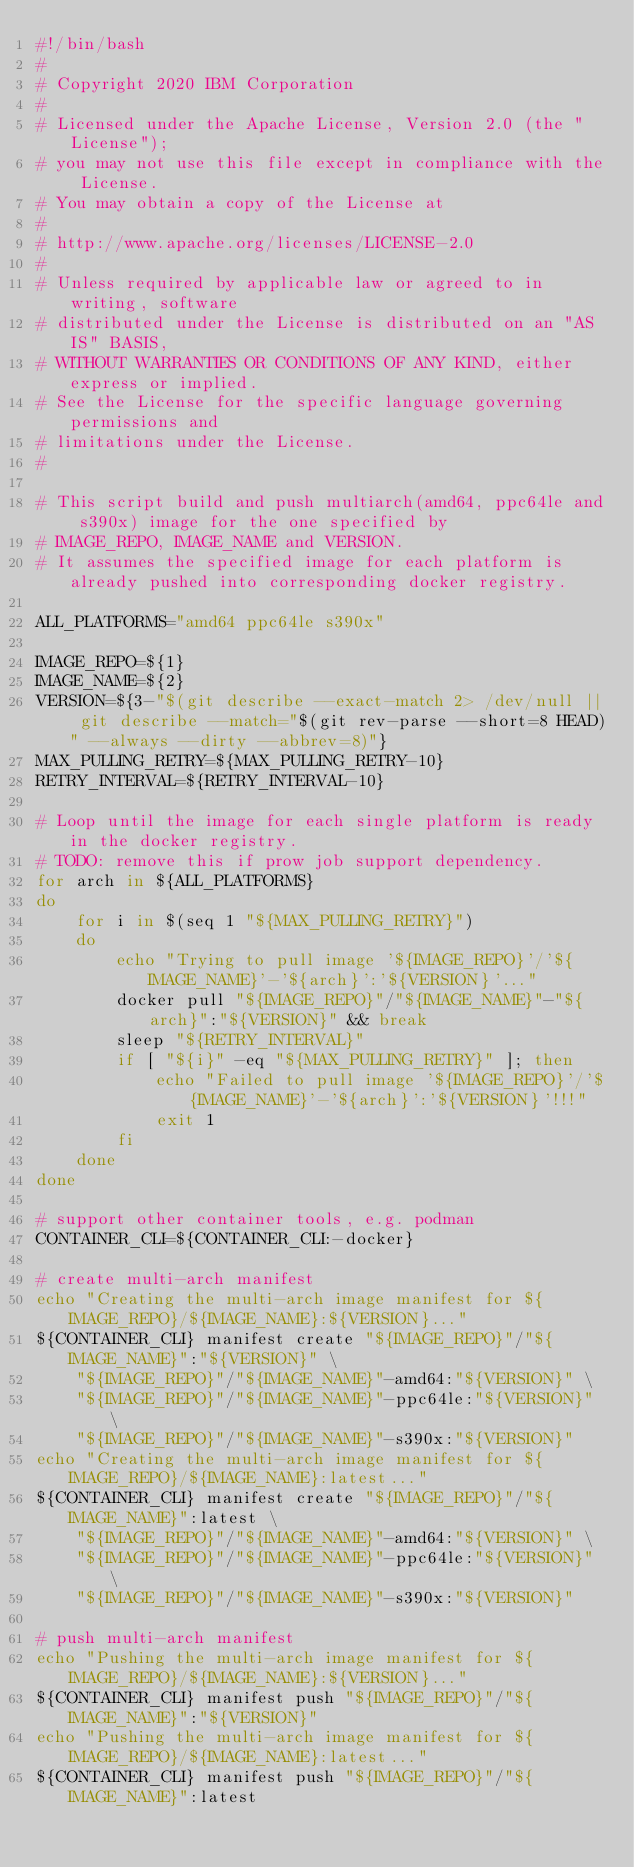Convert code to text. <code><loc_0><loc_0><loc_500><loc_500><_Bash_>#!/bin/bash
#
# Copyright 2020 IBM Corporation
#
# Licensed under the Apache License, Version 2.0 (the "License");
# you may not use this file except in compliance with the License.
# You may obtain a copy of the License at
#
# http://www.apache.org/licenses/LICENSE-2.0
#
# Unless required by applicable law or agreed to in writing, software
# distributed under the License is distributed on an "AS IS" BASIS,
# WITHOUT WARRANTIES OR CONDITIONS OF ANY KIND, either express or implied.
# See the License for the specific language governing permissions and
# limitations under the License.
#

# This script build and push multiarch(amd64, ppc64le and s390x) image for the one specified by
# IMAGE_REPO, IMAGE_NAME and VERSION.
# It assumes the specified image for each platform is already pushed into corresponding docker registry.

ALL_PLATFORMS="amd64 ppc64le s390x"

IMAGE_REPO=${1}
IMAGE_NAME=${2}
VERSION=${3-"$(git describe --exact-match 2> /dev/null || git describe --match="$(git rev-parse --short=8 HEAD)" --always --dirty --abbrev=8)"}
MAX_PULLING_RETRY=${MAX_PULLING_RETRY-10}
RETRY_INTERVAL=${RETRY_INTERVAL-10}

# Loop until the image for each single platform is ready in the docker registry.
# TODO: remove this if prow job support dependency.
for arch in ${ALL_PLATFORMS}
do
    for i in $(seq 1 "${MAX_PULLING_RETRY}")
    do
        echo "Trying to pull image '${IMAGE_REPO}'/'${IMAGE_NAME}'-'${arch}':'${VERSION}'..."
        docker pull "${IMAGE_REPO}"/"${IMAGE_NAME}"-"${arch}":"${VERSION}" && break
        sleep "${RETRY_INTERVAL}"
        if [ "${i}" -eq "${MAX_PULLING_RETRY}" ]; then
            echo "Failed to pull image '${IMAGE_REPO}'/'${IMAGE_NAME}'-'${arch}':'${VERSION}'!!!"
            exit 1
        fi
    done
done

# support other container tools, e.g. podman
CONTAINER_CLI=${CONTAINER_CLI:-docker}

# create multi-arch manifest
echo "Creating the multi-arch image manifest for ${IMAGE_REPO}/${IMAGE_NAME}:${VERSION}..."
${CONTAINER_CLI} manifest create "${IMAGE_REPO}"/"${IMAGE_NAME}":"${VERSION}" \
    "${IMAGE_REPO}"/"${IMAGE_NAME}"-amd64:"${VERSION}" \
    "${IMAGE_REPO}"/"${IMAGE_NAME}"-ppc64le:"${VERSION}" \
    "${IMAGE_REPO}"/"${IMAGE_NAME}"-s390x:"${VERSION}"
echo "Creating the multi-arch image manifest for ${IMAGE_REPO}/${IMAGE_NAME}:latest..."
${CONTAINER_CLI} manifest create "${IMAGE_REPO}"/"${IMAGE_NAME}":latest \
    "${IMAGE_REPO}"/"${IMAGE_NAME}"-amd64:"${VERSION}" \
    "${IMAGE_REPO}"/"${IMAGE_NAME}"-ppc64le:"${VERSION}" \
    "${IMAGE_REPO}"/"${IMAGE_NAME}"-s390x:"${VERSION}"

# push multi-arch manifest
echo "Pushing the multi-arch image manifest for ${IMAGE_REPO}/${IMAGE_NAME}:${VERSION}..."
${CONTAINER_CLI} manifest push "${IMAGE_REPO}"/"${IMAGE_NAME}":"${VERSION}"
echo "Pushing the multi-arch image manifest for ${IMAGE_REPO}/${IMAGE_NAME}:latest..."
${CONTAINER_CLI} manifest push "${IMAGE_REPO}"/"${IMAGE_NAME}":latest
</code> 